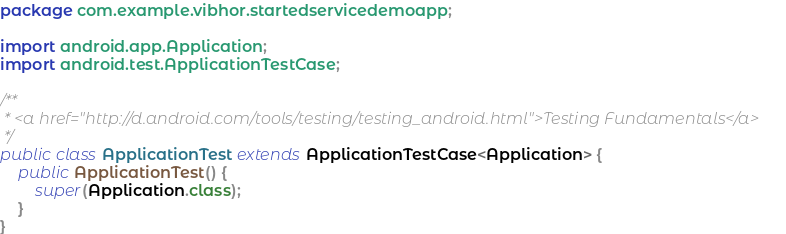<code> <loc_0><loc_0><loc_500><loc_500><_Java_>package com.example.vibhor.startedservicedemoapp;

import android.app.Application;
import android.test.ApplicationTestCase;

/**
 * <a href="http://d.android.com/tools/testing/testing_android.html">Testing Fundamentals</a>
 */
public class ApplicationTest extends ApplicationTestCase<Application> {
    public ApplicationTest() {
        super(Application.class);
    }
}</code> 